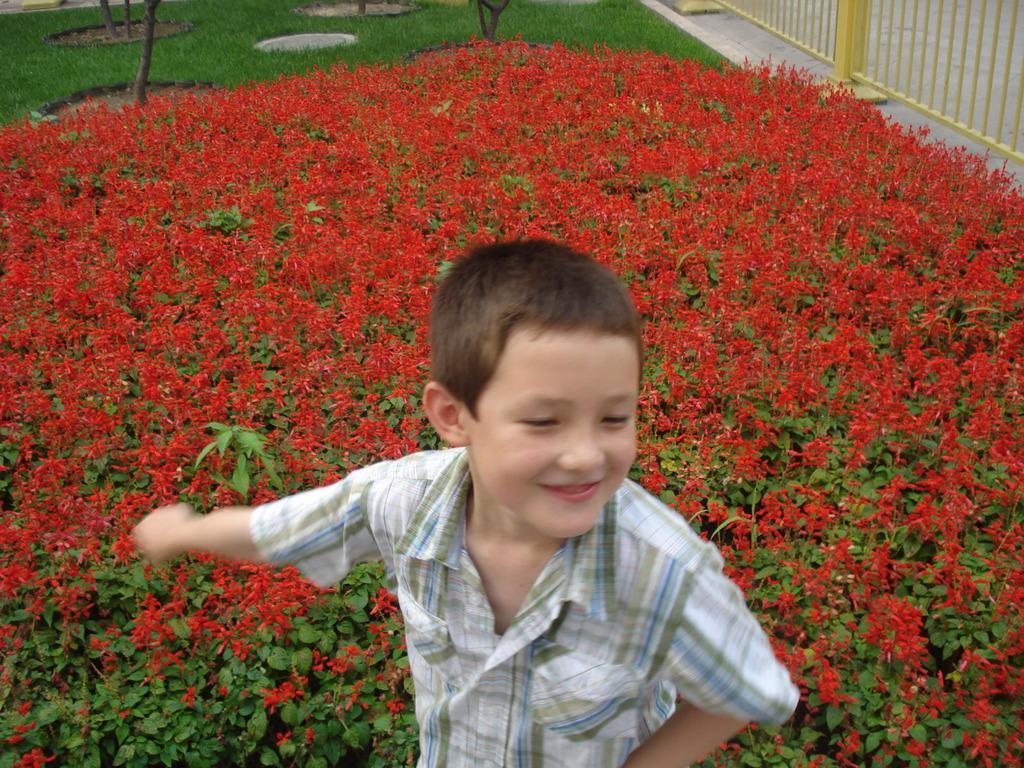Could you give a brief overview of what you see in this image? In this picture there is a boy who is wearing shirt. He is standing on the ground. Behind him we can see red color flowers on the plants. On the top we can see grass. On the top right corner there is a yellow color fencing near to the road. 